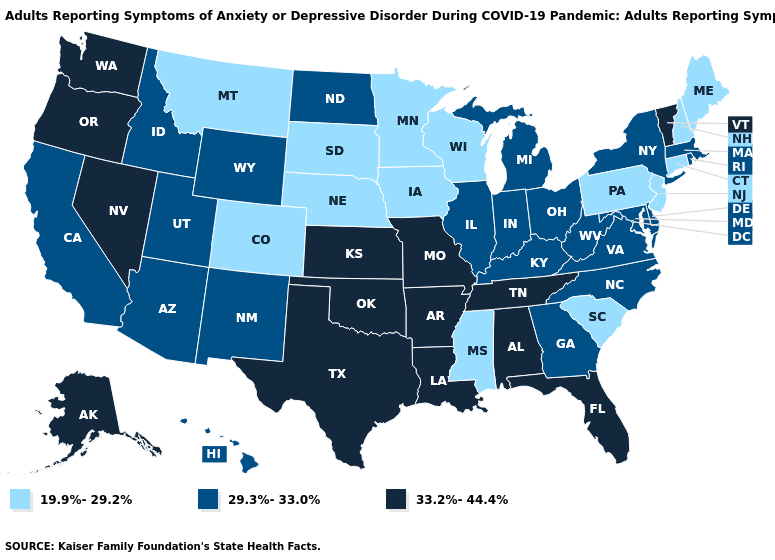What is the value of Rhode Island?
Concise answer only. 29.3%-33.0%. Does South Carolina have the lowest value in the South?
Concise answer only. Yes. How many symbols are there in the legend?
Concise answer only. 3. What is the lowest value in states that border Washington?
Short answer required. 29.3%-33.0%. Among the states that border Oregon , does Idaho have the highest value?
Be succinct. No. What is the highest value in states that border South Dakota?
Quick response, please. 29.3%-33.0%. Does Texas have the lowest value in the USA?
Be succinct. No. Does the first symbol in the legend represent the smallest category?
Keep it brief. Yes. Among the states that border Illinois , does Missouri have the highest value?
Concise answer only. Yes. What is the highest value in states that border Delaware?
Write a very short answer. 29.3%-33.0%. What is the value of Connecticut?
Answer briefly. 19.9%-29.2%. Which states hav the highest value in the West?
Write a very short answer. Alaska, Nevada, Oregon, Washington. What is the value of Washington?
Concise answer only. 33.2%-44.4%. Among the states that border Colorado , does Nebraska have the lowest value?
Write a very short answer. Yes. What is the value of Delaware?
Concise answer only. 29.3%-33.0%. 